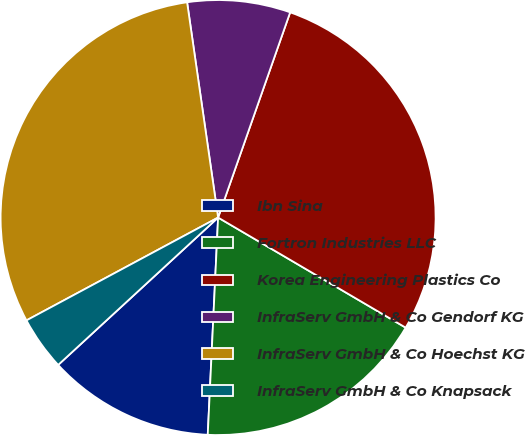Convert chart. <chart><loc_0><loc_0><loc_500><loc_500><pie_chart><fcel>Ibn Sina<fcel>Fortron Industries LLC<fcel>Korea Engineering Plastics Co<fcel>InfraServ GmbH & Co Gendorf KG<fcel>InfraServ GmbH & Co Hoechst KG<fcel>InfraServ GmbH & Co Knapsack<nl><fcel>12.39%<fcel>17.31%<fcel>28.07%<fcel>7.65%<fcel>30.56%<fcel>4.01%<nl></chart> 